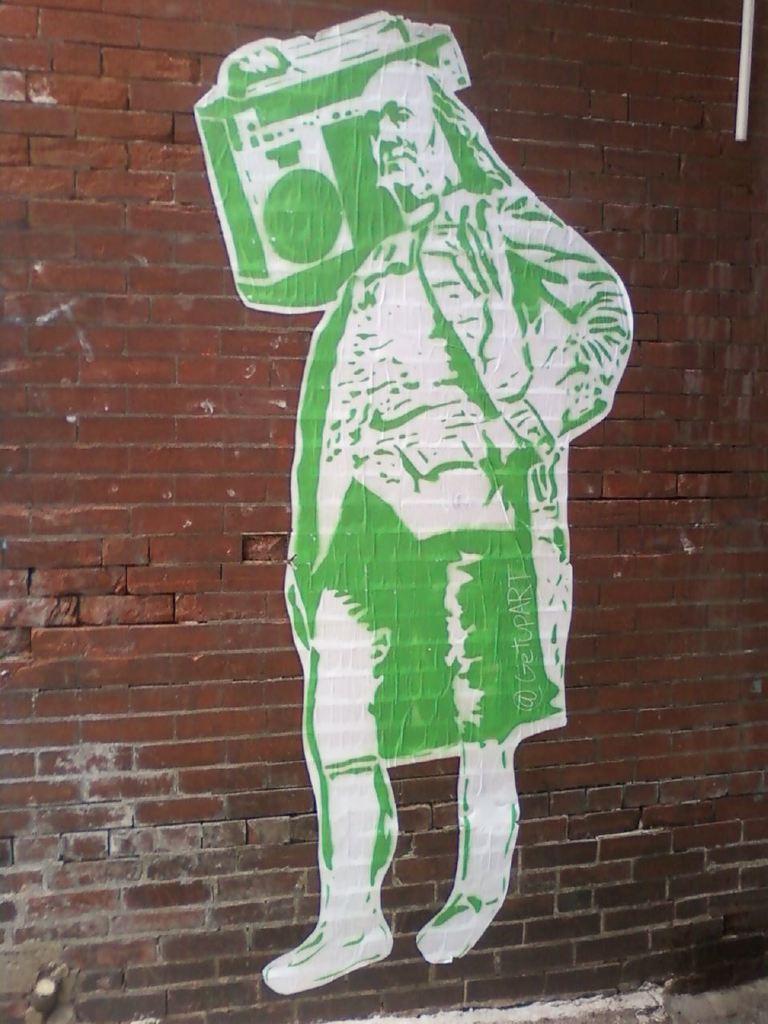Can you describe this image briefly? In this image, we can see a painting of a person holding an object and there is some text on the wall. At the top, we can see a pipe. 